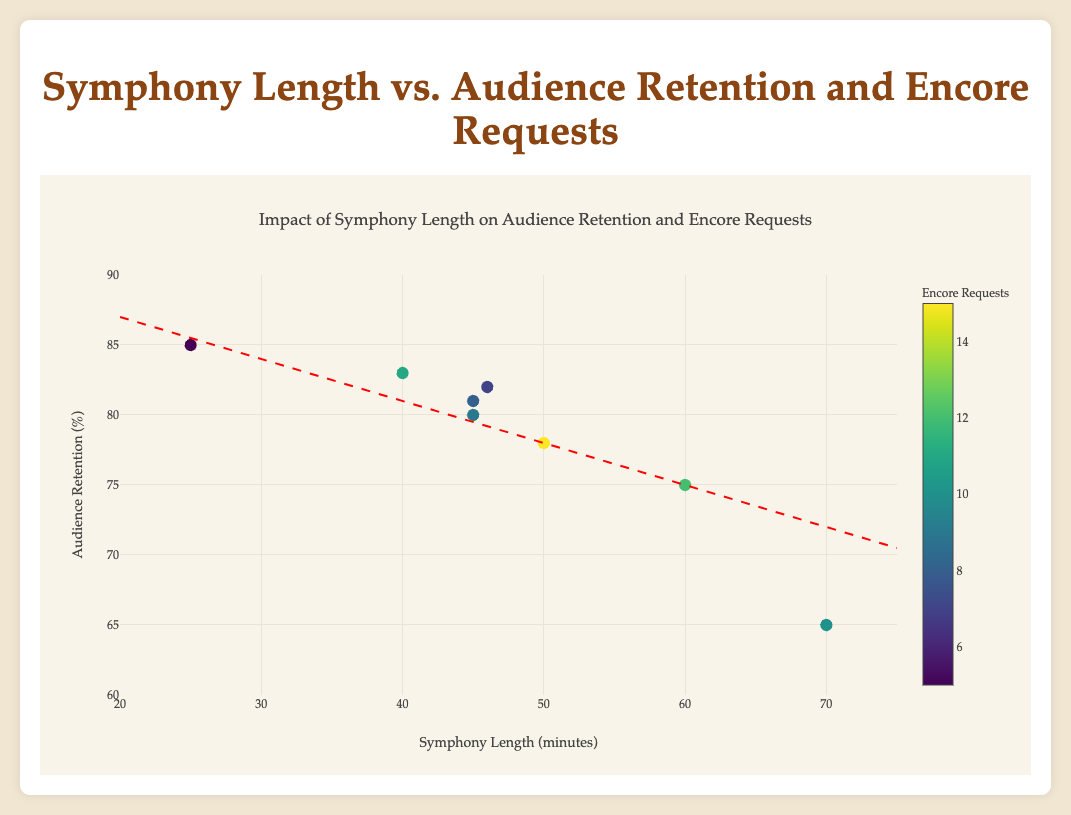What is the title of the figure? The title can be found at the top of the figure in large, bold text with a distinctive color.
Answer: Impact of Symphony Length on Audience Retention and Encore Requests How many symphonies are compared in the plot? Count the number of different data points (markers) present in the plot; each represents a symphony.
Answer: 8 What is the symphony with the highest audience retention percentage? Identify the data point highest on the y-axis and check its corresponding title from the hover text.
Answer: Sinfonietta by Leoš Janáček Which symphony length had the highest number of encore requests? Look at the color scale of the markers and find the darkest (highest value) marker. Then check its corresponding title from the hover text.
Answer: The Planets by Gustav Holst Is there a general relationship between symphony length and audience retention percentage suggested by the trend line? Examine the direction and slope of the trend line to determine the nature of the relationship.
Answer: Yes, there is a slight negative relationship, suggesting longer symphonies might have lower audience retention What is the length and retention percentage of the symphony with the least encore requests? Identify the lightest colored marker in the plot and check its hover text for length and retention percentage.
Answer: Sinfonietta by Leoš Janáček with 25 minutes and 85% retention Which two symphonies have almost equal lengths but different audience retention percentages? Look for markers that are close on the x-axis but have different y-axis values, then compare their lengths and retention percentages.
Answer: Symphony No. 6 by Jean Sibelius and Symphony No. 1 by Johannes Brahms What is the range of symphony lengths covered in the plot? Look at the x-axis to find the minimum and maximum lengths displayed.
Answer: 25 to 70 minutes Compare the audience retention percentage of “Symphony No. 9 by Ludwig van Beethoven” with “Symphony No. 5 by Pyotr Ilyich Tchaikovsky.” Find the data points for these two symphonies and compare their y-axis values.
Answer: Symphony No. 9 has 65%, Symphony No. 5 has 82% What does the color bar represent in the plot, and how is it related to the data points? Identify the color bar on the right side of the plot and its label, then explain how it corresponds to the data points' color.
Answer: Encore requests; it indicates the number of encore requests for each symphony 